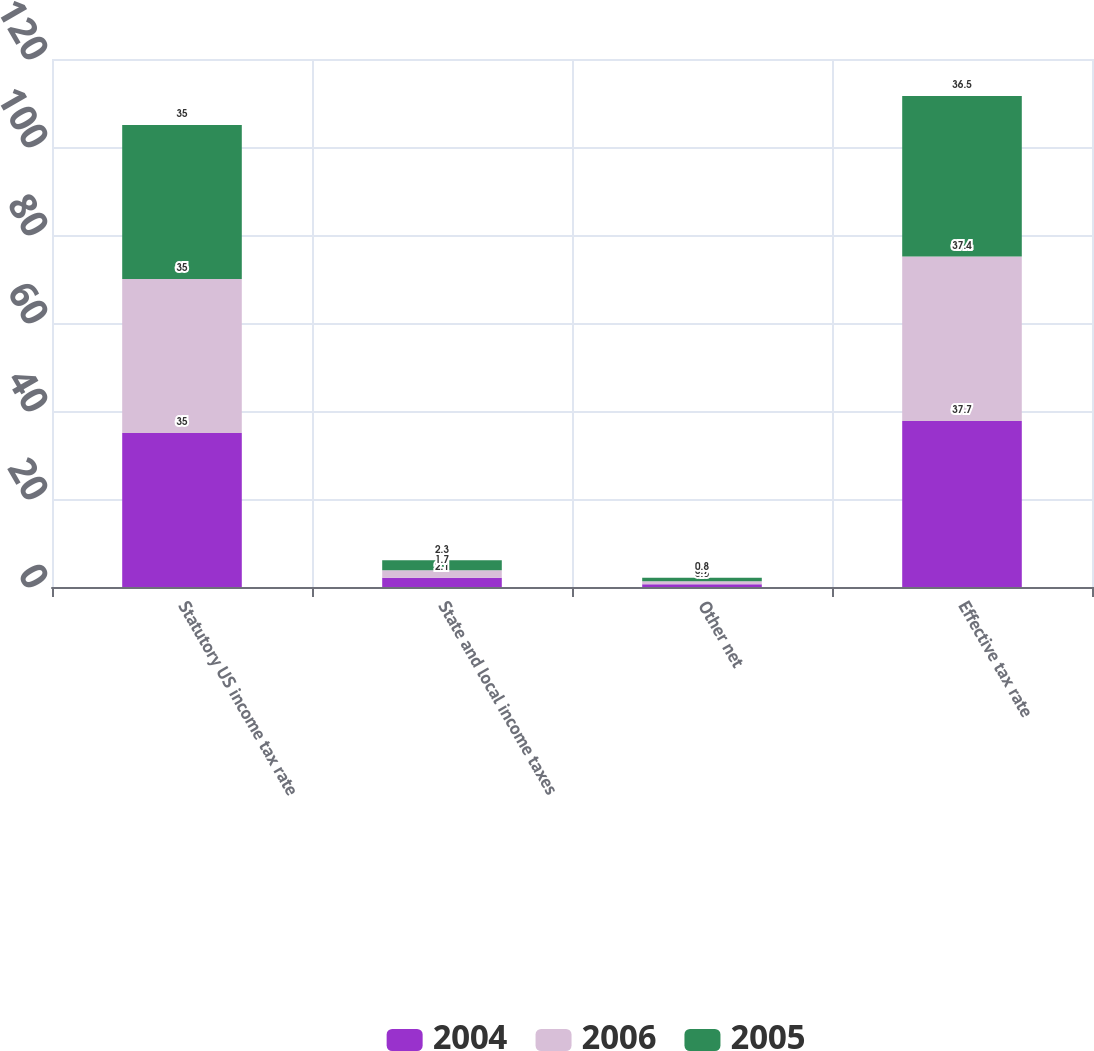<chart> <loc_0><loc_0><loc_500><loc_500><stacked_bar_chart><ecel><fcel>Statutory US income tax rate<fcel>State and local income taxes<fcel>Other net<fcel>Effective tax rate<nl><fcel>2004<fcel>35<fcel>2.1<fcel>0.6<fcel>37.7<nl><fcel>2006<fcel>35<fcel>1.7<fcel>0.7<fcel>37.4<nl><fcel>2005<fcel>35<fcel>2.3<fcel>0.8<fcel>36.5<nl></chart> 